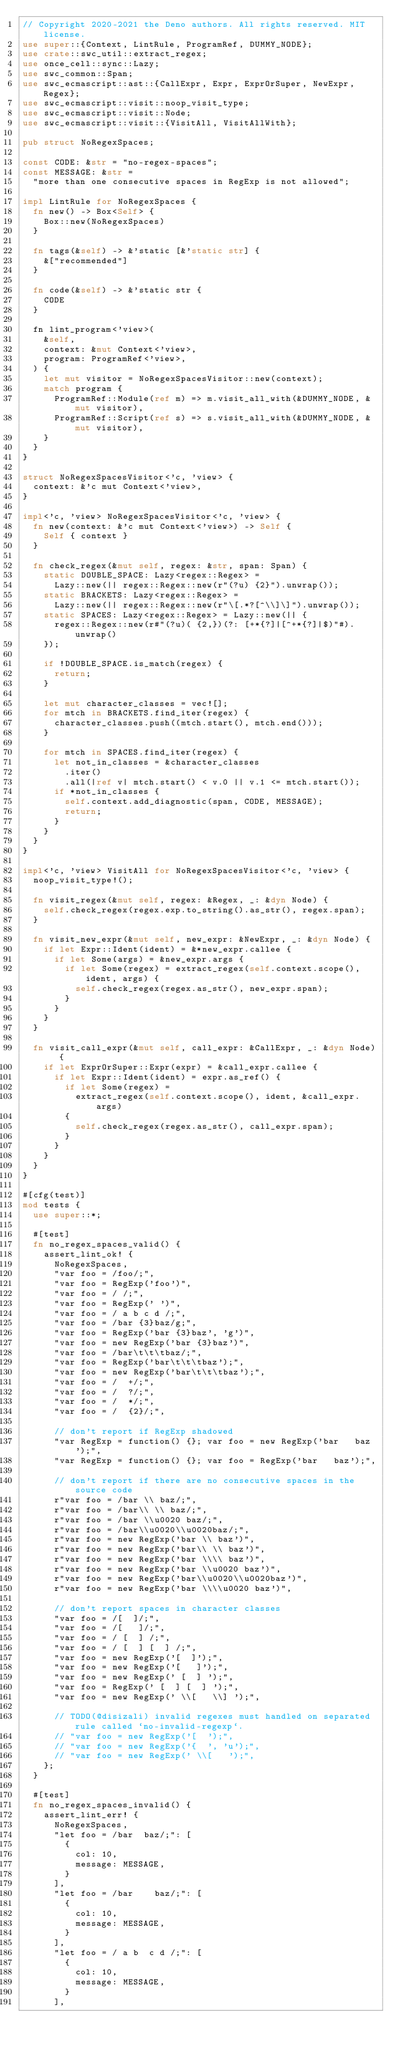<code> <loc_0><loc_0><loc_500><loc_500><_Rust_>// Copyright 2020-2021 the Deno authors. All rights reserved. MIT license.
use super::{Context, LintRule, ProgramRef, DUMMY_NODE};
use crate::swc_util::extract_regex;
use once_cell::sync::Lazy;
use swc_common::Span;
use swc_ecmascript::ast::{CallExpr, Expr, ExprOrSuper, NewExpr, Regex};
use swc_ecmascript::visit::noop_visit_type;
use swc_ecmascript::visit::Node;
use swc_ecmascript::visit::{VisitAll, VisitAllWith};

pub struct NoRegexSpaces;

const CODE: &str = "no-regex-spaces";
const MESSAGE: &str =
  "more than one consecutive spaces in RegExp is not allowed";

impl LintRule for NoRegexSpaces {
  fn new() -> Box<Self> {
    Box::new(NoRegexSpaces)
  }

  fn tags(&self) -> &'static [&'static str] {
    &["recommended"]
  }

  fn code(&self) -> &'static str {
    CODE
  }

  fn lint_program<'view>(
    &self,
    context: &mut Context<'view>,
    program: ProgramRef<'view>,
  ) {
    let mut visitor = NoRegexSpacesVisitor::new(context);
    match program {
      ProgramRef::Module(ref m) => m.visit_all_with(&DUMMY_NODE, &mut visitor),
      ProgramRef::Script(ref s) => s.visit_all_with(&DUMMY_NODE, &mut visitor),
    }
  }
}

struct NoRegexSpacesVisitor<'c, 'view> {
  context: &'c mut Context<'view>,
}

impl<'c, 'view> NoRegexSpacesVisitor<'c, 'view> {
  fn new(context: &'c mut Context<'view>) -> Self {
    Self { context }
  }

  fn check_regex(&mut self, regex: &str, span: Span) {
    static DOUBLE_SPACE: Lazy<regex::Regex> =
      Lazy::new(|| regex::Regex::new(r"(?u) {2}").unwrap());
    static BRACKETS: Lazy<regex::Regex> =
      Lazy::new(|| regex::Regex::new(r"\[.*?[^\\]\]").unwrap());
    static SPACES: Lazy<regex::Regex> = Lazy::new(|| {
      regex::Regex::new(r#"(?u)( {2,})(?: [+*{?]|[^+*{?]|$)"#).unwrap()
    });

    if !DOUBLE_SPACE.is_match(regex) {
      return;
    }

    let mut character_classes = vec![];
    for mtch in BRACKETS.find_iter(regex) {
      character_classes.push((mtch.start(), mtch.end()));
    }

    for mtch in SPACES.find_iter(regex) {
      let not_in_classes = &character_classes
        .iter()
        .all(|ref v| mtch.start() < v.0 || v.1 <= mtch.start());
      if *not_in_classes {
        self.context.add_diagnostic(span, CODE, MESSAGE);
        return;
      }
    }
  }
}

impl<'c, 'view> VisitAll for NoRegexSpacesVisitor<'c, 'view> {
  noop_visit_type!();

  fn visit_regex(&mut self, regex: &Regex, _: &dyn Node) {
    self.check_regex(regex.exp.to_string().as_str(), regex.span);
  }

  fn visit_new_expr(&mut self, new_expr: &NewExpr, _: &dyn Node) {
    if let Expr::Ident(ident) = &*new_expr.callee {
      if let Some(args) = &new_expr.args {
        if let Some(regex) = extract_regex(self.context.scope(), ident, args) {
          self.check_regex(regex.as_str(), new_expr.span);
        }
      }
    }
  }

  fn visit_call_expr(&mut self, call_expr: &CallExpr, _: &dyn Node) {
    if let ExprOrSuper::Expr(expr) = &call_expr.callee {
      if let Expr::Ident(ident) = expr.as_ref() {
        if let Some(regex) =
          extract_regex(self.context.scope(), ident, &call_expr.args)
        {
          self.check_regex(regex.as_str(), call_expr.span);
        }
      }
    }
  }
}

#[cfg(test)]
mod tests {
  use super::*;

  #[test]
  fn no_regex_spaces_valid() {
    assert_lint_ok! {
      NoRegexSpaces,
      "var foo = /foo/;",
      "var foo = RegExp('foo')",
      "var foo = / /;",
      "var foo = RegExp(' ')",
      "var foo = / a b c d /;",
      "var foo = /bar {3}baz/g;",
      "var foo = RegExp('bar {3}baz', 'g')",
      "var foo = new RegExp('bar {3}baz')",
      "var foo = /bar\t\t\tbaz/;",
      "var foo = RegExp('bar\t\t\tbaz');",
      "var foo = new RegExp('bar\t\t\tbaz');",
      "var foo = /  +/;",
      "var foo = /  ?/;",
      "var foo = /  */;",
      "var foo = /  {2}/;",

      // don't report if RegExp shadowed
      "var RegExp = function() {}; var foo = new RegExp('bar   baz');",
      "var RegExp = function() {}; var foo = RegExp('bar   baz');",

      // don't report if there are no consecutive spaces in the source code
      r"var foo = /bar \\ baz/;",
      r"var foo = /bar\\ \\ baz/;",
      r"var foo = /bar \\u0020 baz/;",
      r"var foo = /bar\\u0020\\u0020baz/;",
      r"var foo = new RegExp('bar \\ baz')",
      r"var foo = new RegExp('bar\\ \\ baz')",
      r"var foo = new RegExp('bar \\\\ baz')",
      r"var foo = new RegExp('bar \\u0020 baz')",
      r"var foo = new RegExp('bar\\u0020\\u0020baz')",
      r"var foo = new RegExp('bar \\\\u0020 baz')",

      // don't report spaces in character classes
      "var foo = /[  ]/;",
      "var foo = /[   ]/;",
      "var foo = / [  ] /;",
      "var foo = / [  ] [  ] /;",
      "var foo = new RegExp('[  ]');",
      "var foo = new RegExp('[   ]');",
      "var foo = new RegExp(' [  ] ');",
      "var foo = RegExp(' [  ] [  ] ');",
      "var foo = new RegExp(' \\[   \\] ');",

      // TODO(@disizali) invalid regexes must handled on separated rule called `no-invalid-regexp`.
      // "var foo = new RegExp('[  ');",
      // "var foo = new RegExp('{  ', 'u');",
      // "var foo = new RegExp(' \\[   ');",
    };
  }

  #[test]
  fn no_regex_spaces_invalid() {
    assert_lint_err! {
      NoRegexSpaces,
      "let foo = /bar  baz/;": [
        {
          col: 10,
          message: MESSAGE,
        }
      ],
      "let foo = /bar    baz/;": [
        {
          col: 10,
          message: MESSAGE,
        }
      ],
      "let foo = / a b  c d /;": [
        {
          col: 10,
          message: MESSAGE,
        }
      ],</code> 